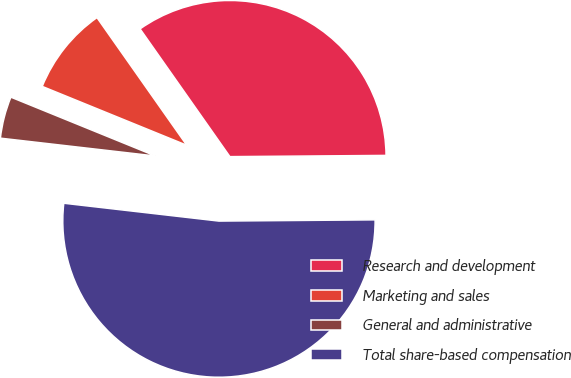Convert chart. <chart><loc_0><loc_0><loc_500><loc_500><pie_chart><fcel>Research and development<fcel>Marketing and sales<fcel>General and administrative<fcel>Total share-based compensation<nl><fcel>34.63%<fcel>9.09%<fcel>4.33%<fcel>51.95%<nl></chart> 